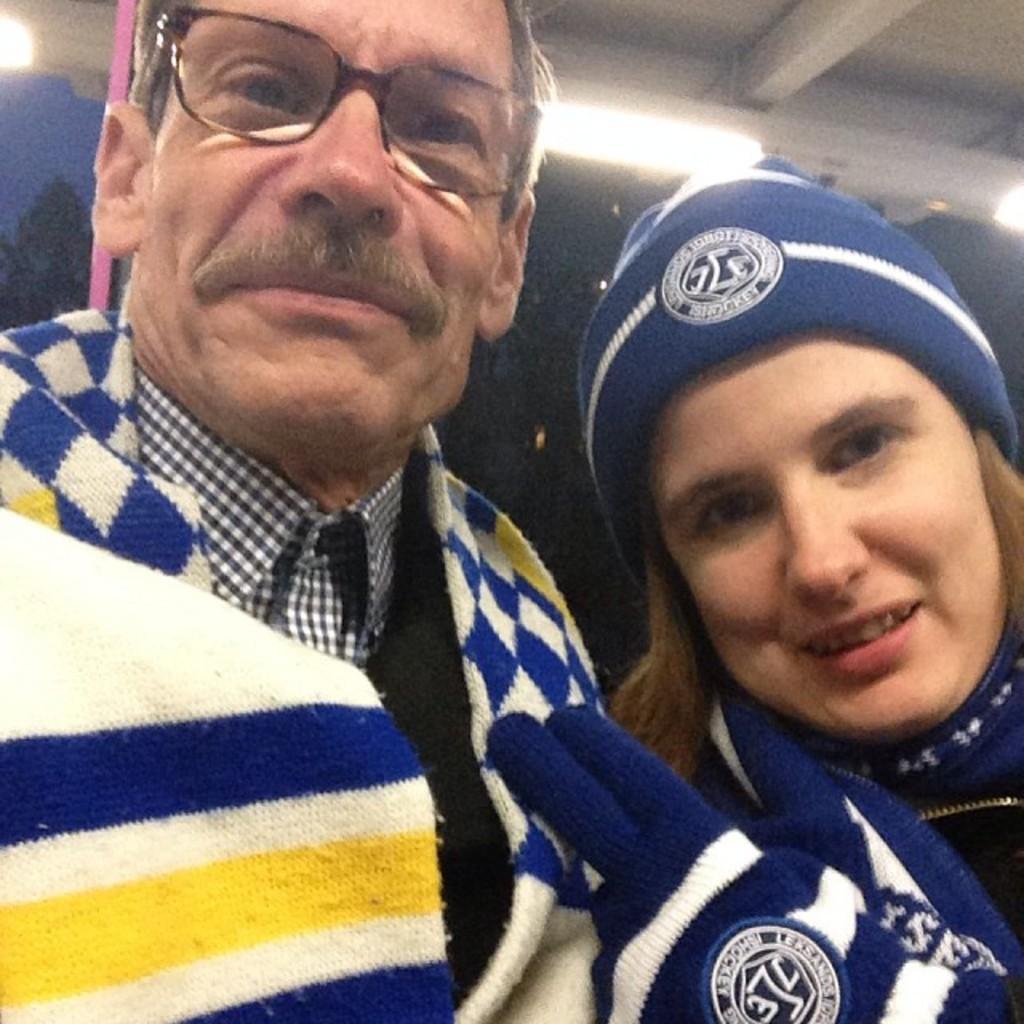Describe this image in one or two sentences. In this picture there is a girl and a lamp in the center of the image and there are lamps at the top side of the image. 